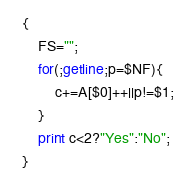Convert code to text. <code><loc_0><loc_0><loc_500><loc_500><_Awk_>{
    FS="";
    for(;getline;p=$NF){
        c+=A[$0]++||p!=$1;
    }
    print c<2?"Yes":"No";
}</code> 